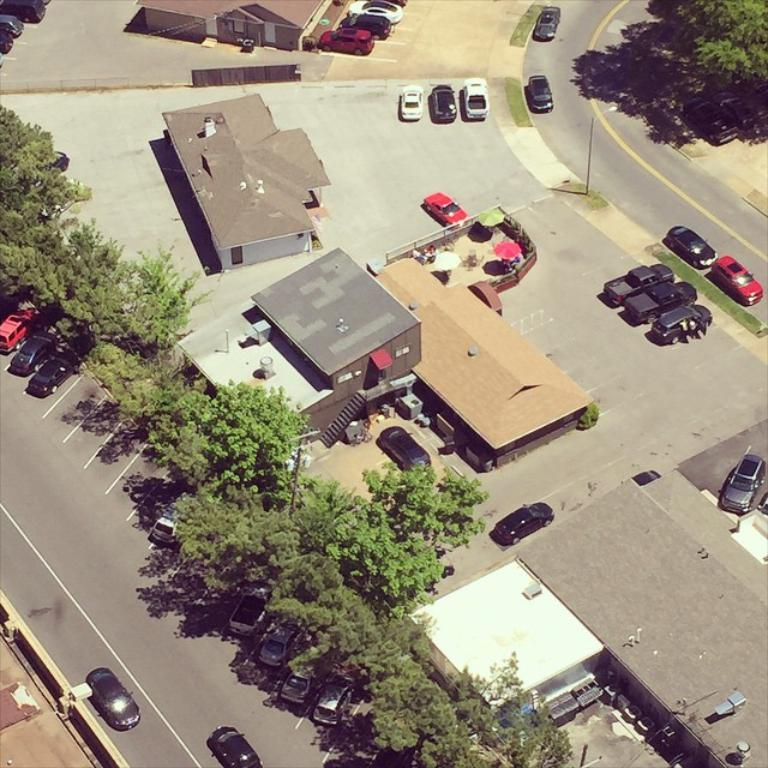What type of structures can be seen in the image? There are buildings in the image. What natural elements are present in the image? There are trees in the image. What are the vertical objects in the image? There are poles in the image. What type of transportation is visible in the image? There are vehicles on the road in the image. What else can be seen in the image that is not a structure or a natural element? There are wires in the image. Can you see a locket hanging from the trees in the image? There is no locket hanging from the trees in the image. What type of arm is visible in the image? There are no arms visible in the image. 